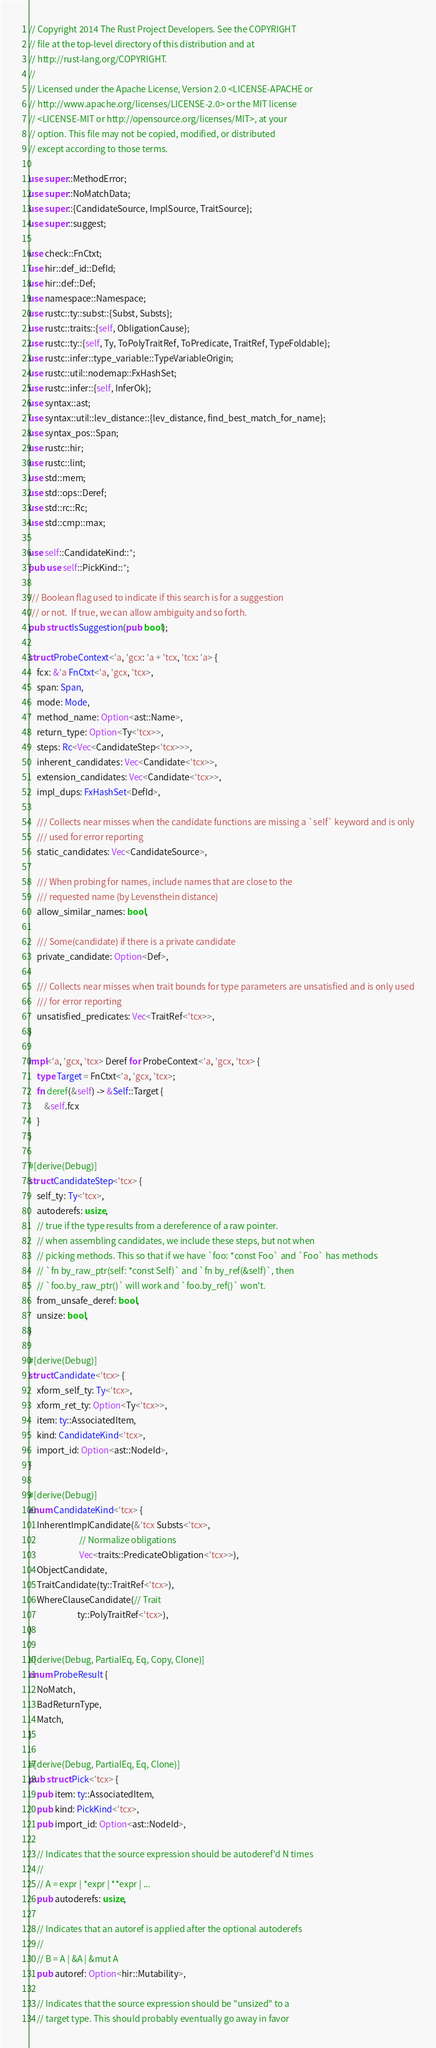<code> <loc_0><loc_0><loc_500><loc_500><_Rust_>// Copyright 2014 The Rust Project Developers. See the COPYRIGHT
// file at the top-level directory of this distribution and at
// http://rust-lang.org/COPYRIGHT.
//
// Licensed under the Apache License, Version 2.0 <LICENSE-APACHE or
// http://www.apache.org/licenses/LICENSE-2.0> or the MIT license
// <LICENSE-MIT or http://opensource.org/licenses/MIT>, at your
// option. This file may not be copied, modified, or distributed
// except according to those terms.

use super::MethodError;
use super::NoMatchData;
use super::{CandidateSource, ImplSource, TraitSource};
use super::suggest;

use check::FnCtxt;
use hir::def_id::DefId;
use hir::def::Def;
use namespace::Namespace;
use rustc::ty::subst::{Subst, Substs};
use rustc::traits::{self, ObligationCause};
use rustc::ty::{self, Ty, ToPolyTraitRef, ToPredicate, TraitRef, TypeFoldable};
use rustc::infer::type_variable::TypeVariableOrigin;
use rustc::util::nodemap::FxHashSet;
use rustc::infer::{self, InferOk};
use syntax::ast;
use syntax::util::lev_distance::{lev_distance, find_best_match_for_name};
use syntax_pos::Span;
use rustc::hir;
use rustc::lint;
use std::mem;
use std::ops::Deref;
use std::rc::Rc;
use std::cmp::max;

use self::CandidateKind::*;
pub use self::PickKind::*;

/// Boolean flag used to indicate if this search is for a suggestion
/// or not.  If true, we can allow ambiguity and so forth.
pub struct IsSuggestion(pub bool);

struct ProbeContext<'a, 'gcx: 'a + 'tcx, 'tcx: 'a> {
    fcx: &'a FnCtxt<'a, 'gcx, 'tcx>,
    span: Span,
    mode: Mode,
    method_name: Option<ast::Name>,
    return_type: Option<Ty<'tcx>>,
    steps: Rc<Vec<CandidateStep<'tcx>>>,
    inherent_candidates: Vec<Candidate<'tcx>>,
    extension_candidates: Vec<Candidate<'tcx>>,
    impl_dups: FxHashSet<DefId>,

    /// Collects near misses when the candidate functions are missing a `self` keyword and is only
    /// used for error reporting
    static_candidates: Vec<CandidateSource>,

    /// When probing for names, include names that are close to the
    /// requested name (by Levensthein distance)
    allow_similar_names: bool,

    /// Some(candidate) if there is a private candidate
    private_candidate: Option<Def>,

    /// Collects near misses when trait bounds for type parameters are unsatisfied and is only used
    /// for error reporting
    unsatisfied_predicates: Vec<TraitRef<'tcx>>,
}

impl<'a, 'gcx, 'tcx> Deref for ProbeContext<'a, 'gcx, 'tcx> {
    type Target = FnCtxt<'a, 'gcx, 'tcx>;
    fn deref(&self) -> &Self::Target {
        &self.fcx
    }
}

#[derive(Debug)]
struct CandidateStep<'tcx> {
    self_ty: Ty<'tcx>,
    autoderefs: usize,
    // true if the type results from a dereference of a raw pointer.
    // when assembling candidates, we include these steps, but not when
    // picking methods. This so that if we have `foo: *const Foo` and `Foo` has methods
    // `fn by_raw_ptr(self: *const Self)` and `fn by_ref(&self)`, then
    // `foo.by_raw_ptr()` will work and `foo.by_ref()` won't.
    from_unsafe_deref: bool,
    unsize: bool,
}

#[derive(Debug)]
struct Candidate<'tcx> {
    xform_self_ty: Ty<'tcx>,
    xform_ret_ty: Option<Ty<'tcx>>,
    item: ty::AssociatedItem,
    kind: CandidateKind<'tcx>,
    import_id: Option<ast::NodeId>,
}

#[derive(Debug)]
enum CandidateKind<'tcx> {
    InherentImplCandidate(&'tcx Substs<'tcx>,
                          // Normalize obligations
                          Vec<traits::PredicateObligation<'tcx>>),
    ObjectCandidate,
    TraitCandidate(ty::TraitRef<'tcx>),
    WhereClauseCandidate(// Trait
                         ty::PolyTraitRef<'tcx>),
}

#[derive(Debug, PartialEq, Eq, Copy, Clone)]
enum ProbeResult {
    NoMatch,
    BadReturnType,
    Match,
}

#[derive(Debug, PartialEq, Eq, Clone)]
pub struct Pick<'tcx> {
    pub item: ty::AssociatedItem,
    pub kind: PickKind<'tcx>,
    pub import_id: Option<ast::NodeId>,

    // Indicates that the source expression should be autoderef'd N times
    //
    // A = expr | *expr | **expr | ...
    pub autoderefs: usize,

    // Indicates that an autoref is applied after the optional autoderefs
    //
    // B = A | &A | &mut A
    pub autoref: Option<hir::Mutability>,

    // Indicates that the source expression should be "unsized" to a
    // target type. This should probably eventually go away in favor</code> 